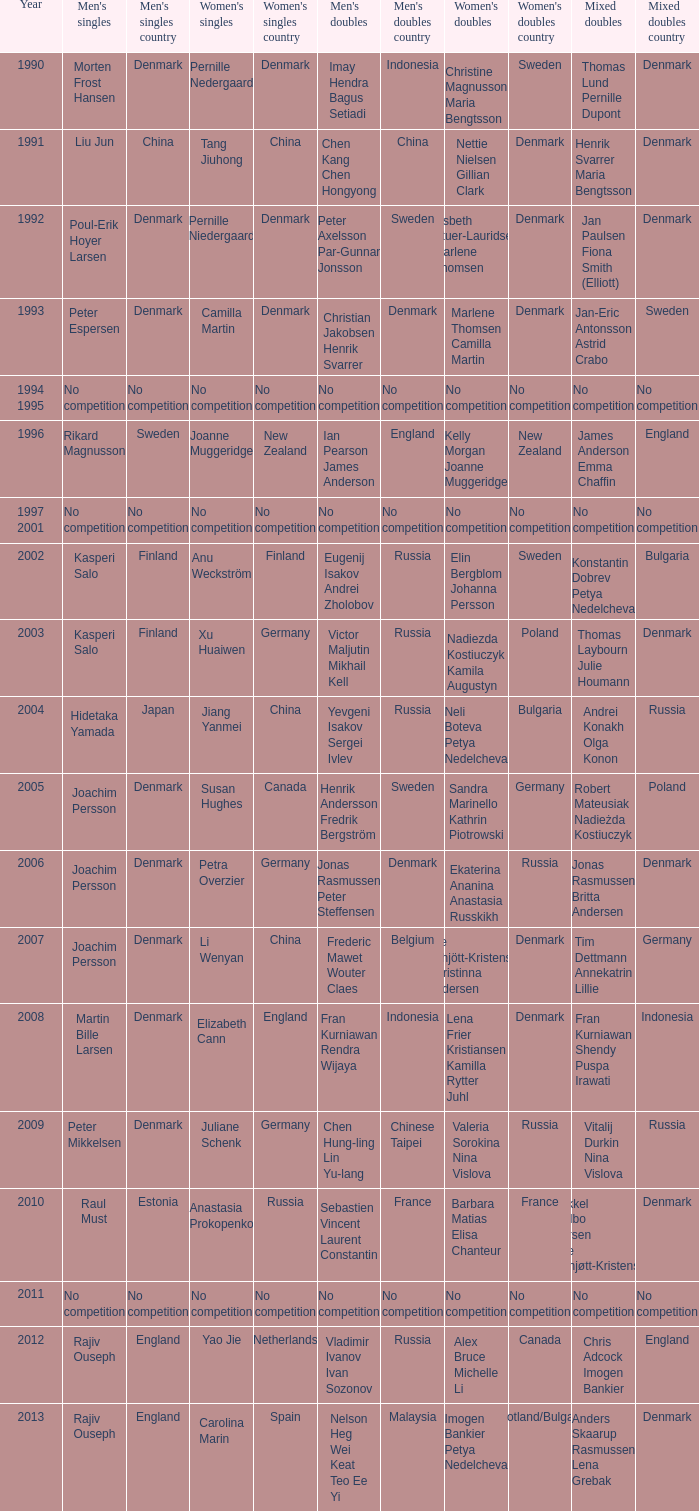Who triumphed in the mixed doubles when juliane schenk secured the women's singles? Vitalij Durkin Nina Vislova. 